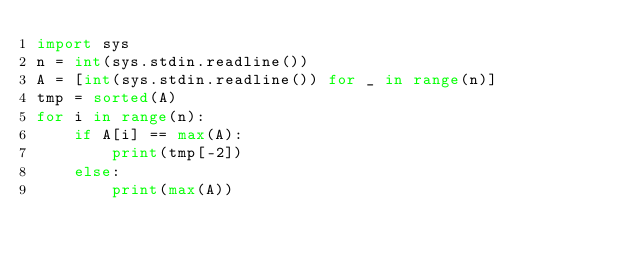Convert code to text. <code><loc_0><loc_0><loc_500><loc_500><_Python_>import sys
n = int(sys.stdin.readline())
A = [int(sys.stdin.readline()) for _ in range(n)]
tmp = sorted(A)
for i in range(n):
    if A[i] == max(A):
        print(tmp[-2])
    else:
        print(max(A))</code> 